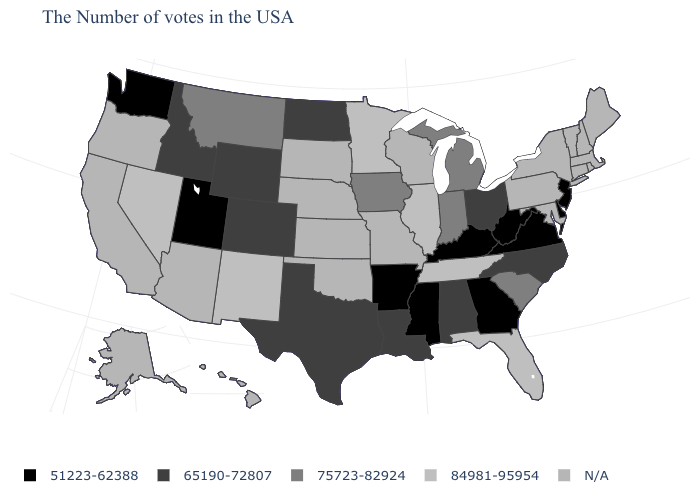What is the value of South Carolina?
Short answer required. 75723-82924. Name the states that have a value in the range 84981-95954?
Short answer required. Florida, Tennessee, Illinois, Minnesota, New Mexico, Nevada. How many symbols are there in the legend?
Write a very short answer. 5. Name the states that have a value in the range 65190-72807?
Short answer required. North Carolina, Ohio, Alabama, Louisiana, Texas, North Dakota, Wyoming, Colorado, Idaho. Does Wyoming have the highest value in the West?
Give a very brief answer. No. Name the states that have a value in the range 75723-82924?
Write a very short answer. South Carolina, Michigan, Indiana, Iowa, Montana. What is the value of Illinois?
Keep it brief. 84981-95954. Among the states that border Minnesota , does Iowa have the highest value?
Concise answer only. Yes. Does Illinois have the lowest value in the MidWest?
Write a very short answer. No. How many symbols are there in the legend?
Keep it brief. 5. What is the highest value in states that border Florida?
Give a very brief answer. 65190-72807. 